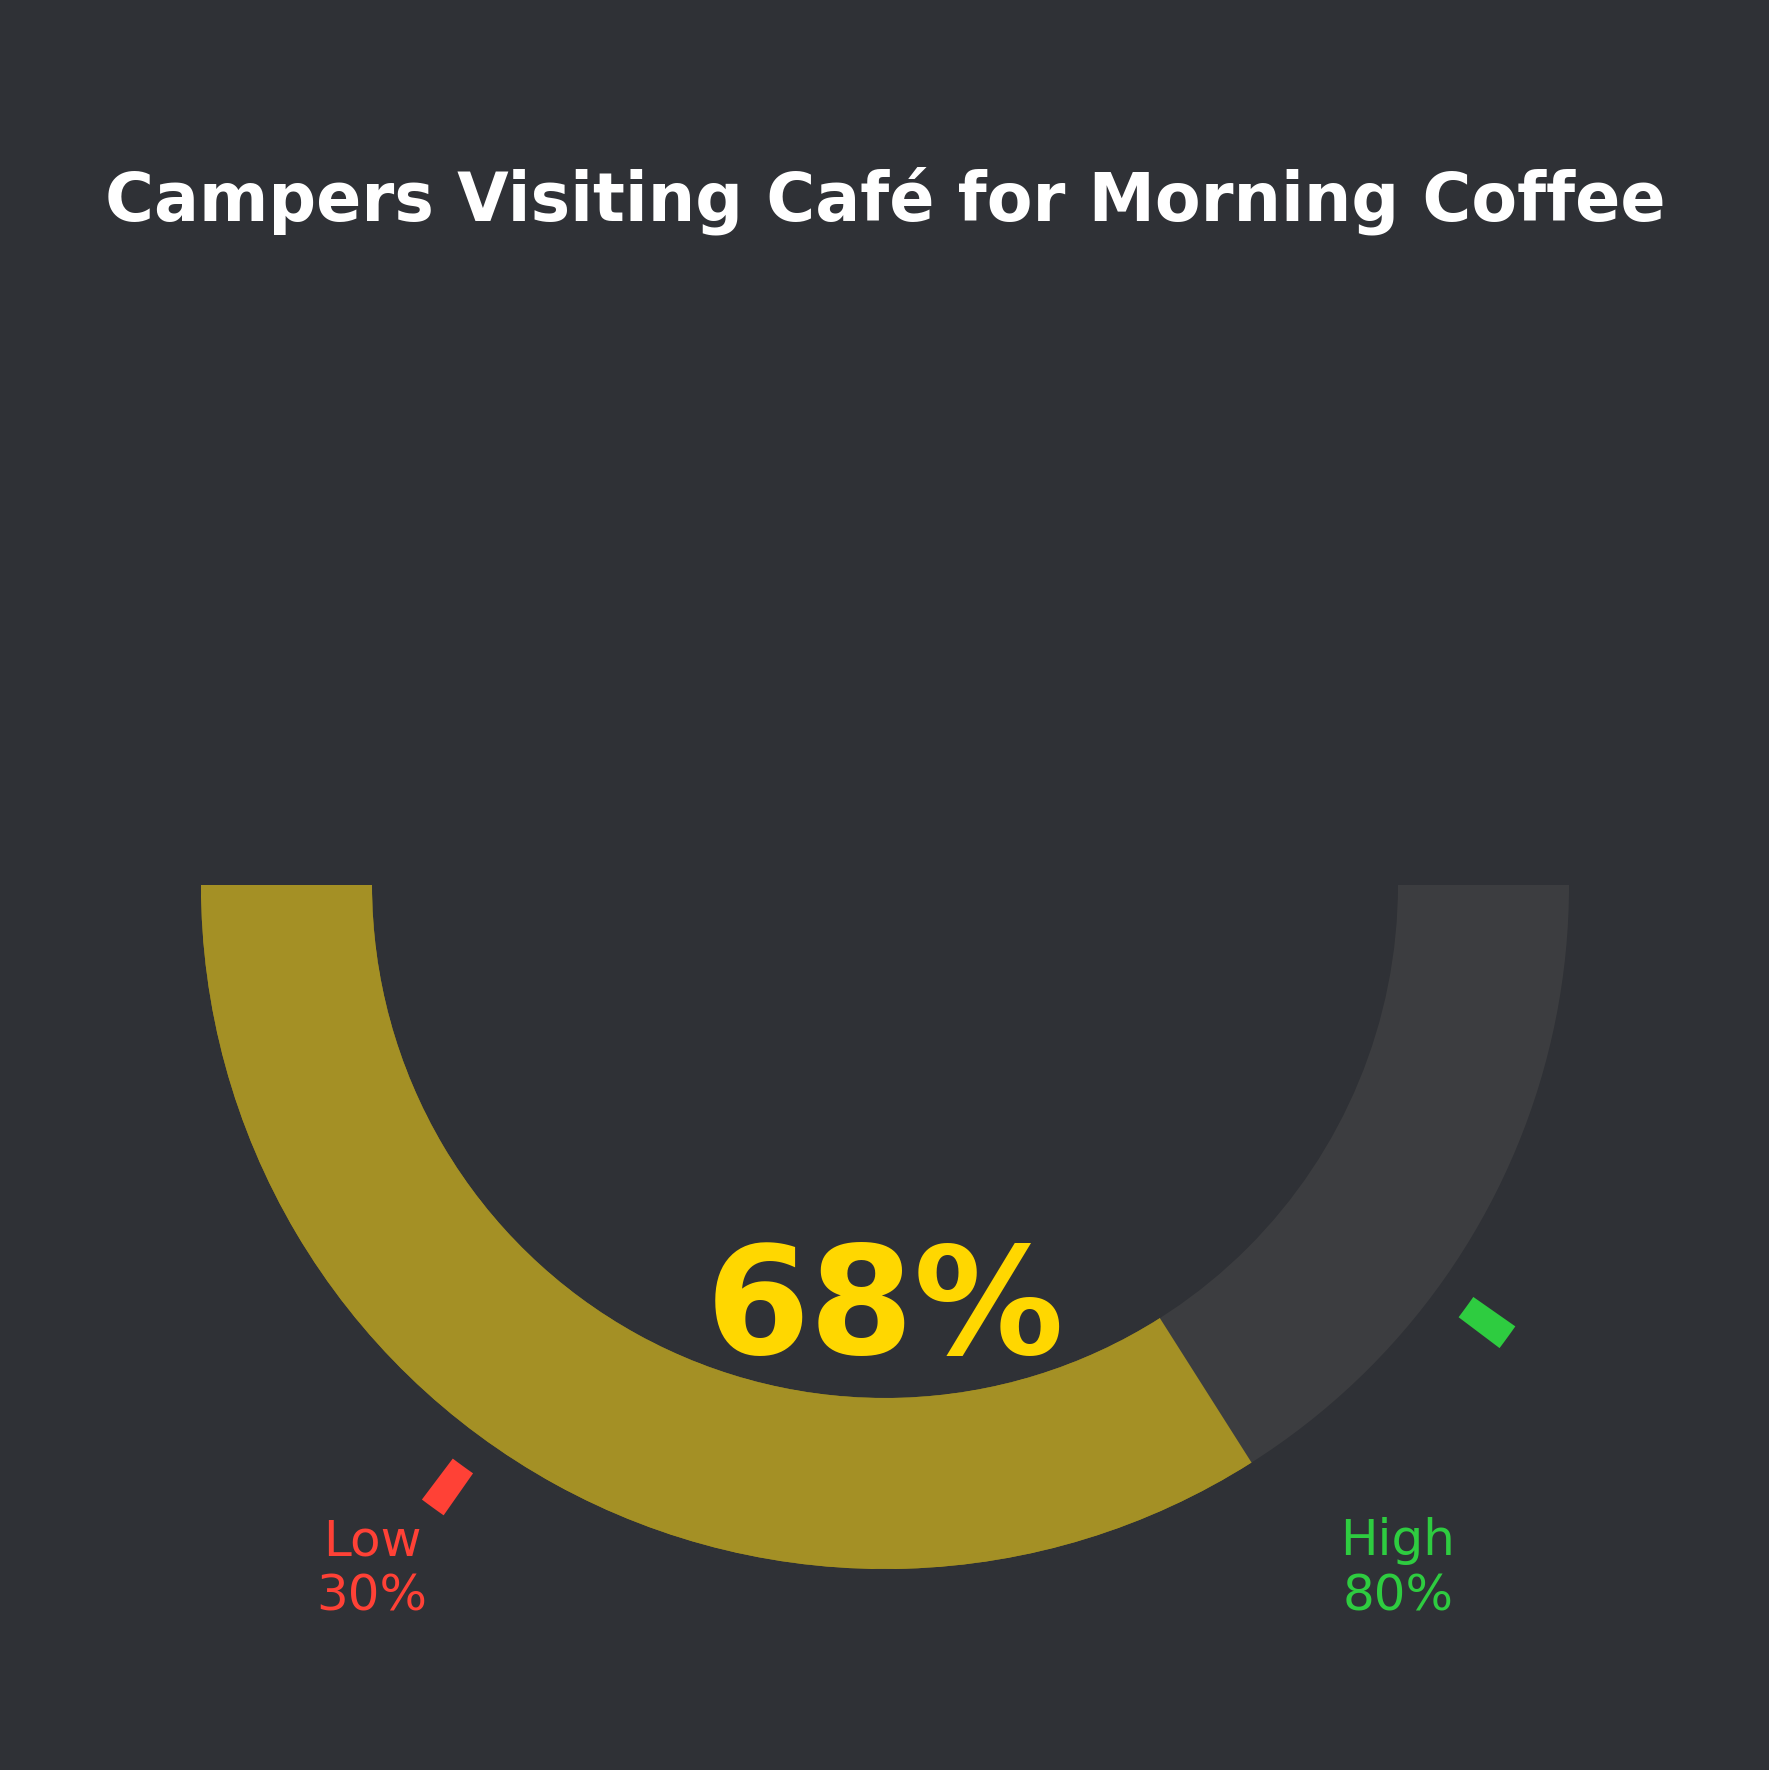What percentage of campers visit the café for morning coffee? The gauge chart shows a percentage marked in a bright yellow color. This percentage is 68%, clearly written above the gauge.
Answer: 68% What is the low threshold value? The gauge chart has thresholds marked, with the low threshold indicated with a label "Low" and percentage "30%" in red color at the left bottom side.
Answer: 30% What is the high threshold value? The high threshold is marked on the gauge with a label "High" and percentage "80%" in green color at the right bottom side.
Answer: 80% Is the percentage of campers visiting the café above the low threshold? The low threshold is 30%. The percentage of campers visiting the café is 68%, which is greater than 30%.
Answer: Yes Is the percentage of campers visiting the café below the high threshold? The high threshold is 80%. The percentage of campers visiting the café is 68%, which is less than 80%.
Answer: Yes How much above the low threshold is the current percentage of campers visiting the café? The current percentage of campers visiting the café is 68%, and the low threshold is 30%. The difference is calculated as 68% - 30% = 38%.
Answer: 38% How much below the high threshold is the current percentage of campers visiting the café? The current percentage of campers visiting the café is 68%, and the high threshold is 80%. The difference is calculated as 80% - 68% = 12%.
Answer: 12% What is the mid-point of the low and high thresholds, and does the current percentage exceed this mid-point? The mid-point between the low and high thresholds (30% and 80%) is calculated as (30 + 80) / 2 = 55%. The current percentage visiting the café is 68%, which exceeds 55%.
Answer: Yes, mid-point is 55%, and current percentage exceeds it What color represents the current percentage of campers visiting the café in the gauge? The wedge showing the current percentage is in a bright yellow color, indicating the percentage marker on the gauge chart.
Answer: Yellow 